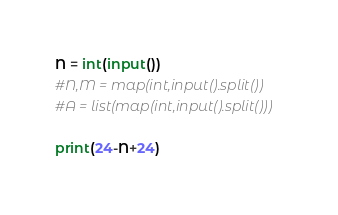Convert code to text. <code><loc_0><loc_0><loc_500><loc_500><_Python_>N = int(input())
#N,M = map(int,input().split())
#A = list(map(int,input().split()))

print(24-N+24)</code> 